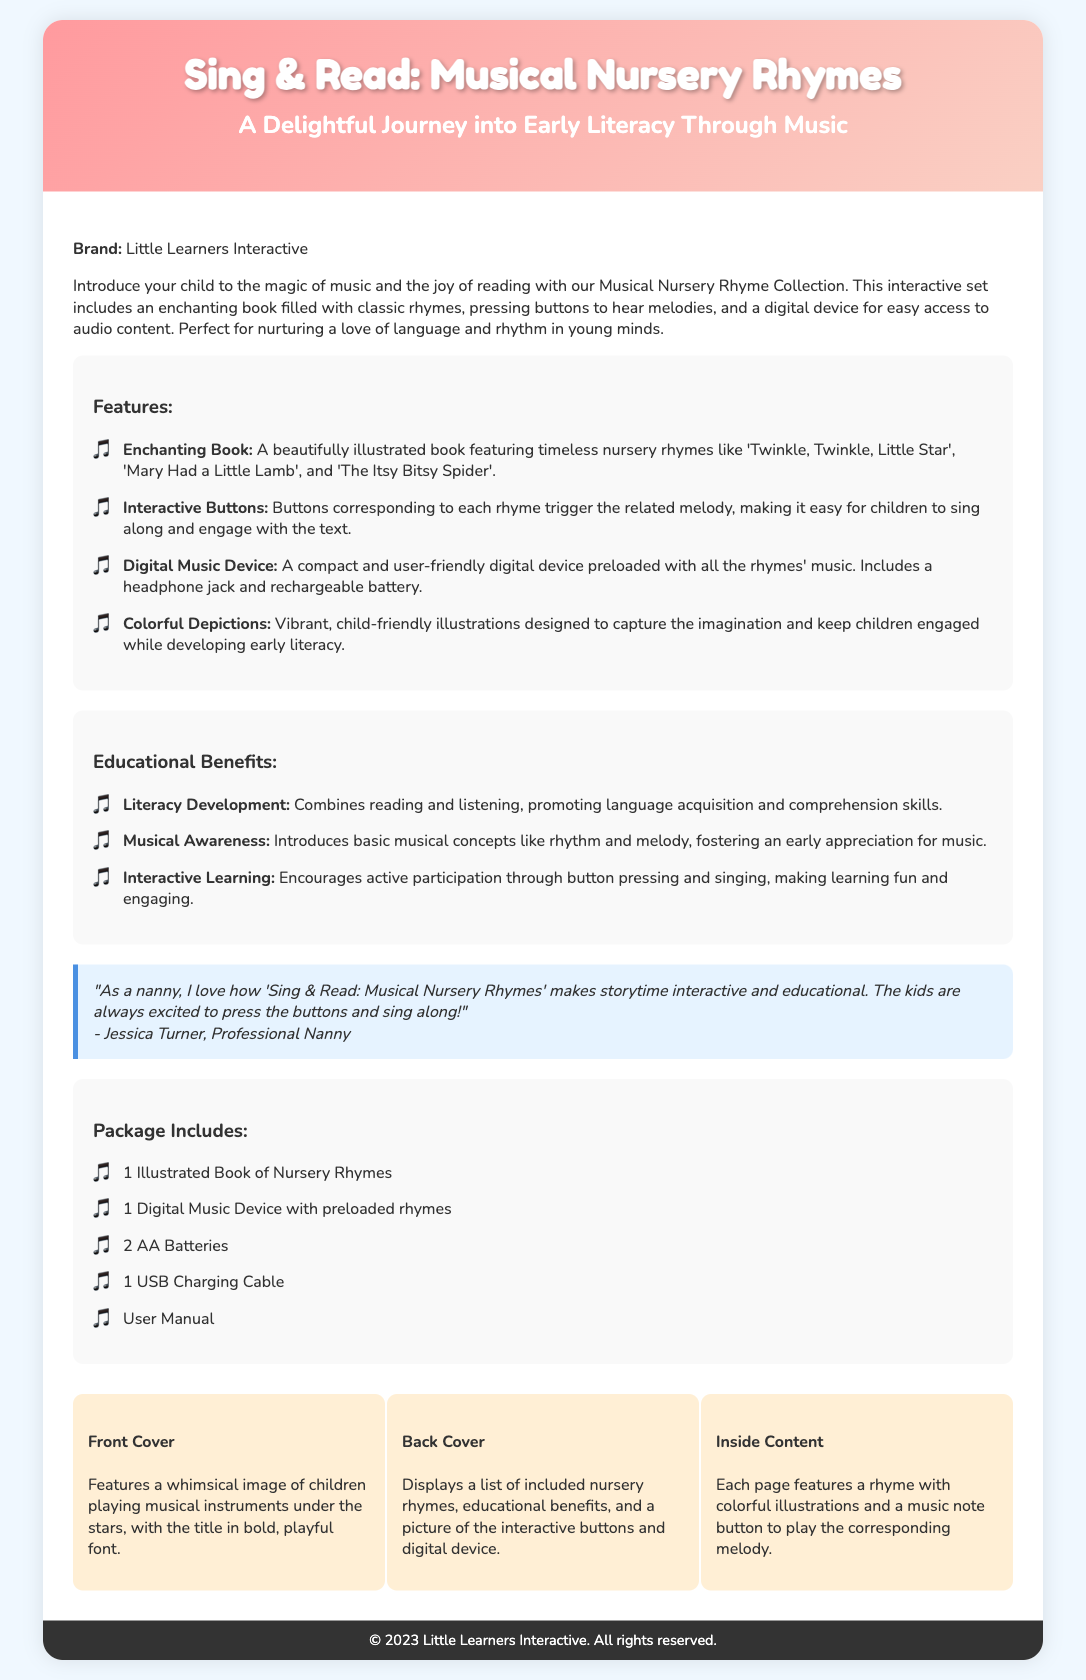What is the brand name? The brand name for the product is mentioned at the beginning of the content section.
Answer: Little Learners Interactive How many nursery rhymes are included in the illustrated book? The document describes that classic nursery rhymes are featured, but does not specify a quantity. However, it does suggest multiple rhymes like 'Twinkle, Twinkle, Little Star' and 'Mary Had a Little Lamb'.
Answer: Multiple What type of device comes with the package? The document specifies the type of device included in the package that corresponds to the nursery rhymes.
Answer: Digital Music Device What color is the background of the packaging? The background color of the document is stated in the body style section of the code.
Answer: Light Blue What is one benefit of the Musical Nursery Rhyme Collection? The document lists educational benefits of the product; one is highlighted as fostering language skills.
Answer: Literacy Development How many AA batteries are included? This is specified directly in the package content section of the document.
Answer: 2 AA Batteries What feature accompanies each nursery rhyme in the book? The document explains that each nursery rhyme has a specific feature that enhances interactivity while reading.
Answer: Music note button What is the style of the front cover? The front cover description is provided in the visual elements section, specifying its design.
Answer: Whimsical image of children playing musical instruments 